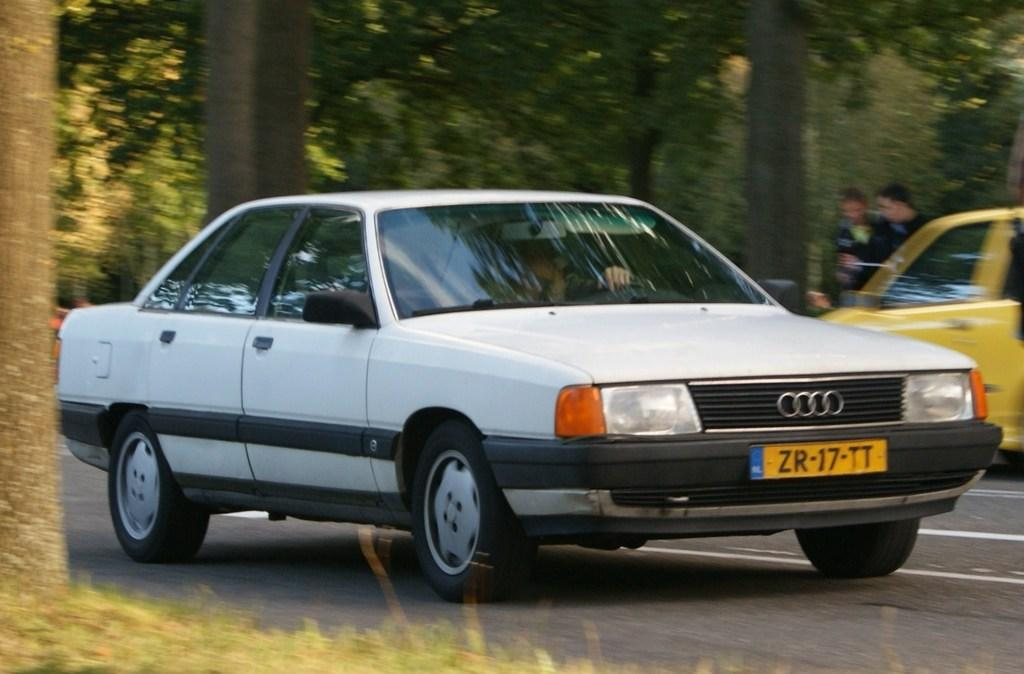What is the main feature of the image? There is a road in the image. What can be seen on the road? There are vehicles on the road. What type of vegetation is present near the road? There are trees on the sides of the road. Can you describe the people in the background of the image? There are two people in the background of the image. What type of flesh can be seen hanging from the trees in the image? There is no flesh hanging from the trees in the image; it features a road with vehicles and trees. 